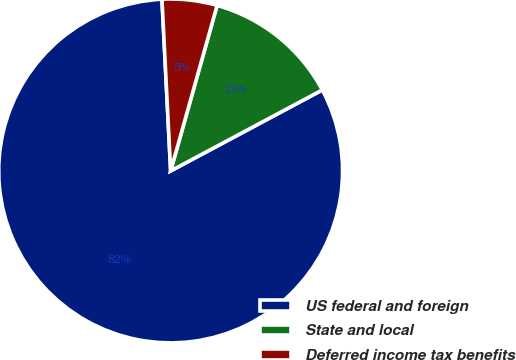Convert chart to OTSL. <chart><loc_0><loc_0><loc_500><loc_500><pie_chart><fcel>US federal and foreign<fcel>State and local<fcel>Deferred income tax benefits<nl><fcel>82.0%<fcel>12.84%<fcel>5.16%<nl></chart> 